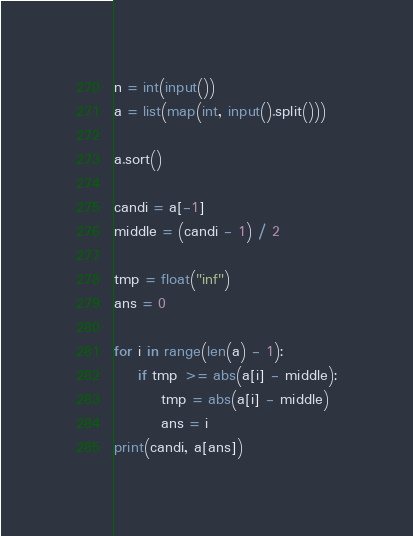<code> <loc_0><loc_0><loc_500><loc_500><_Python_>n = int(input())
a = list(map(int, input().split()))

a.sort()

candi = a[-1]
middle = (candi - 1) / 2

tmp = float("inf")
ans = 0

for i in range(len(a) - 1):
    if tmp >= abs(a[i] - middle):
        tmp = abs(a[i] - middle)
        ans = i
print(candi, a[ans])</code> 